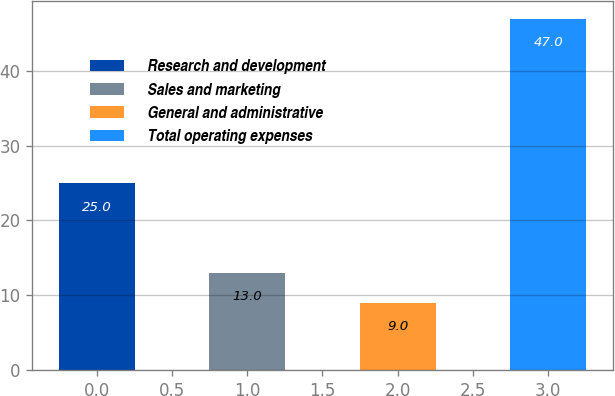<chart> <loc_0><loc_0><loc_500><loc_500><bar_chart><fcel>Research and development<fcel>Sales and marketing<fcel>General and administrative<fcel>Total operating expenses<nl><fcel>25<fcel>13<fcel>9<fcel>47<nl></chart> 